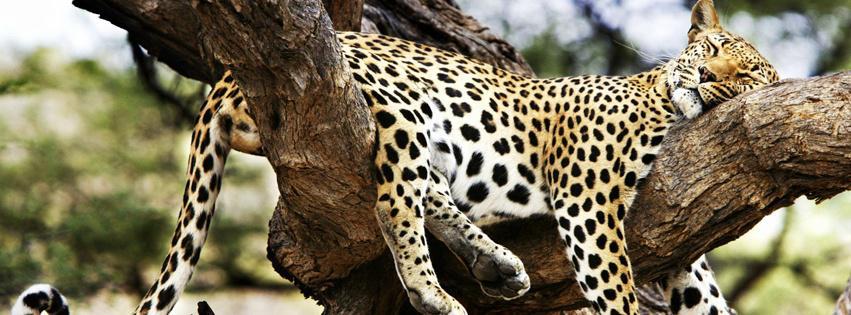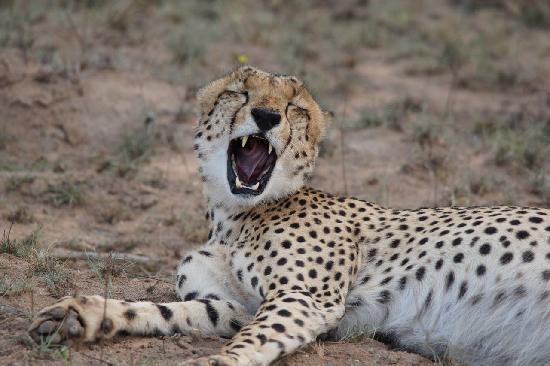The first image is the image on the left, the second image is the image on the right. Examine the images to the left and right. Is the description "One of the cheetahs is yawning" accurate? Answer yes or no. Yes. The first image is the image on the left, the second image is the image on the right. Given the left and right images, does the statement "The cat in the image on the right has its mouth open wide." hold true? Answer yes or no. Yes. 